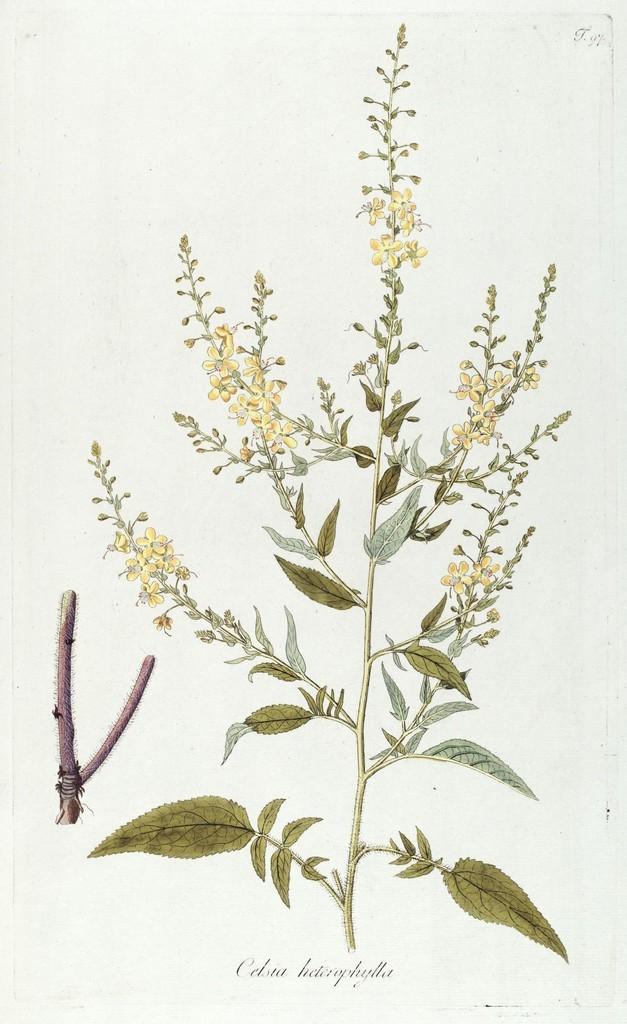Can you describe this image briefly? It is the painting of a plant with beautiful flowers. 